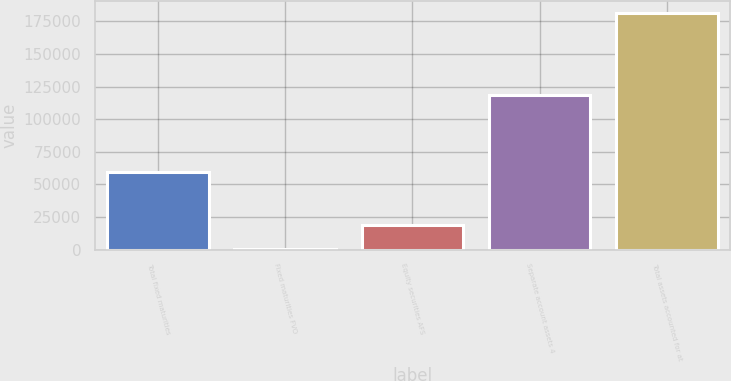Convert chart to OTSL. <chart><loc_0><loc_0><loc_500><loc_500><bar_chart><fcel>Total fixed maturities<fcel>Fixed maturities FVO<fcel>Equity securities AFS<fcel>Separate account assets 4<fcel>Total assets accounted for at<nl><fcel>59196<fcel>503<fcel>18616<fcel>118174<fcel>181633<nl></chart> 